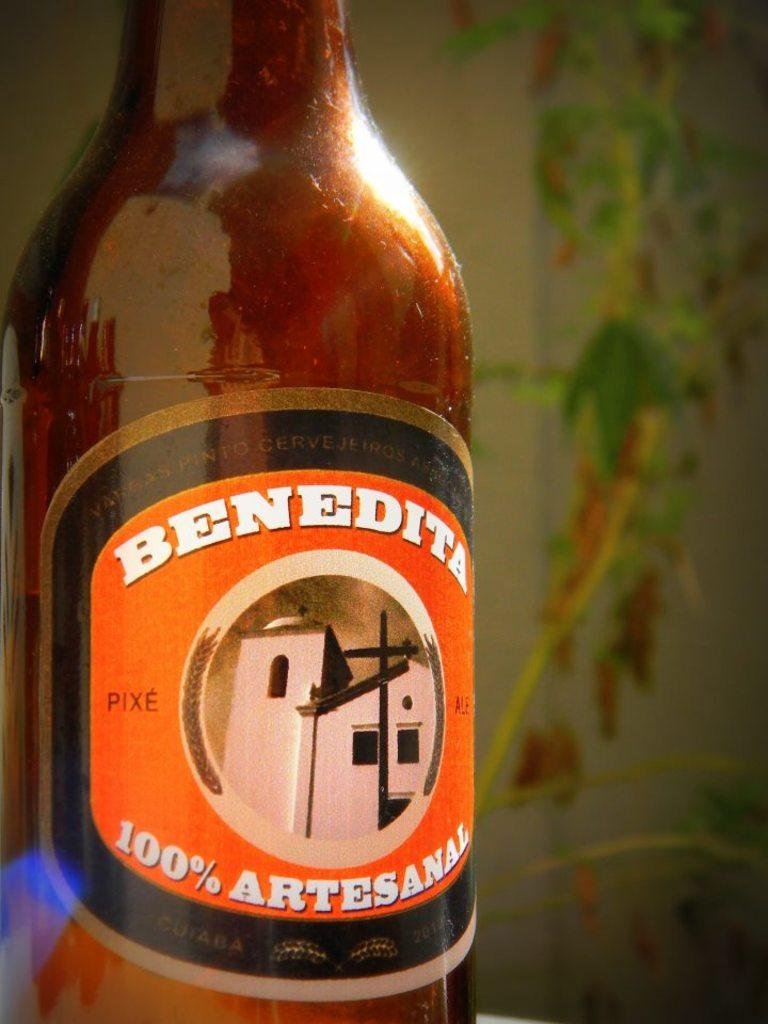<image>
Present a compact description of the photo's key features. a bottle of Benedita 100% Artesanal type of drink 